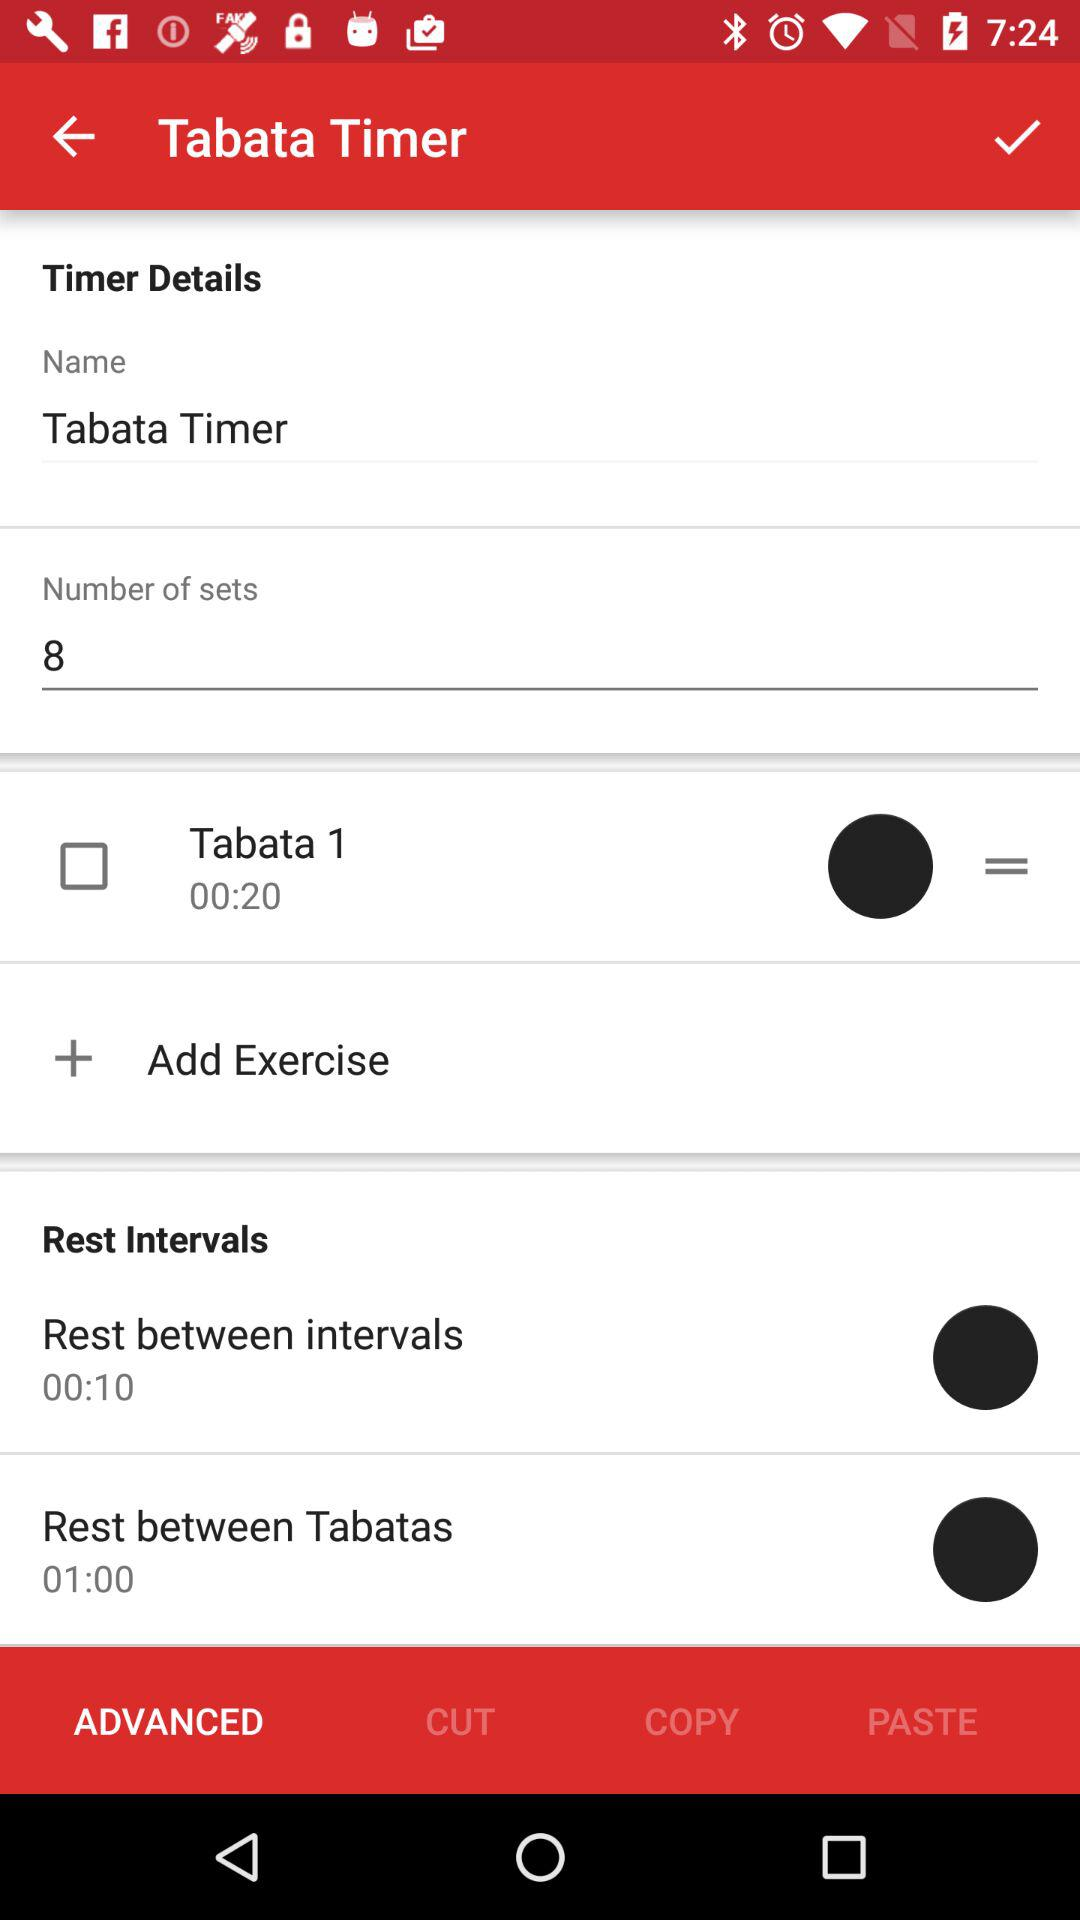How long is the rest between intervals?
Answer the question using a single word or phrase. 00:10 